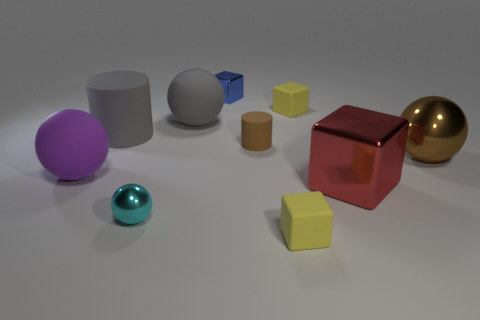Subtract all big spheres. How many spheres are left? 1 Subtract 1 cubes. How many cubes are left? 3 Subtract all yellow spheres. Subtract all cyan cylinders. How many spheres are left? 4 Subtract all spheres. How many objects are left? 6 Add 2 big red metal objects. How many big red metal objects are left? 3 Add 2 big green objects. How many big green objects exist? 2 Subtract 1 brown spheres. How many objects are left? 9 Subtract all large gray balls. Subtract all metallic cubes. How many objects are left? 7 